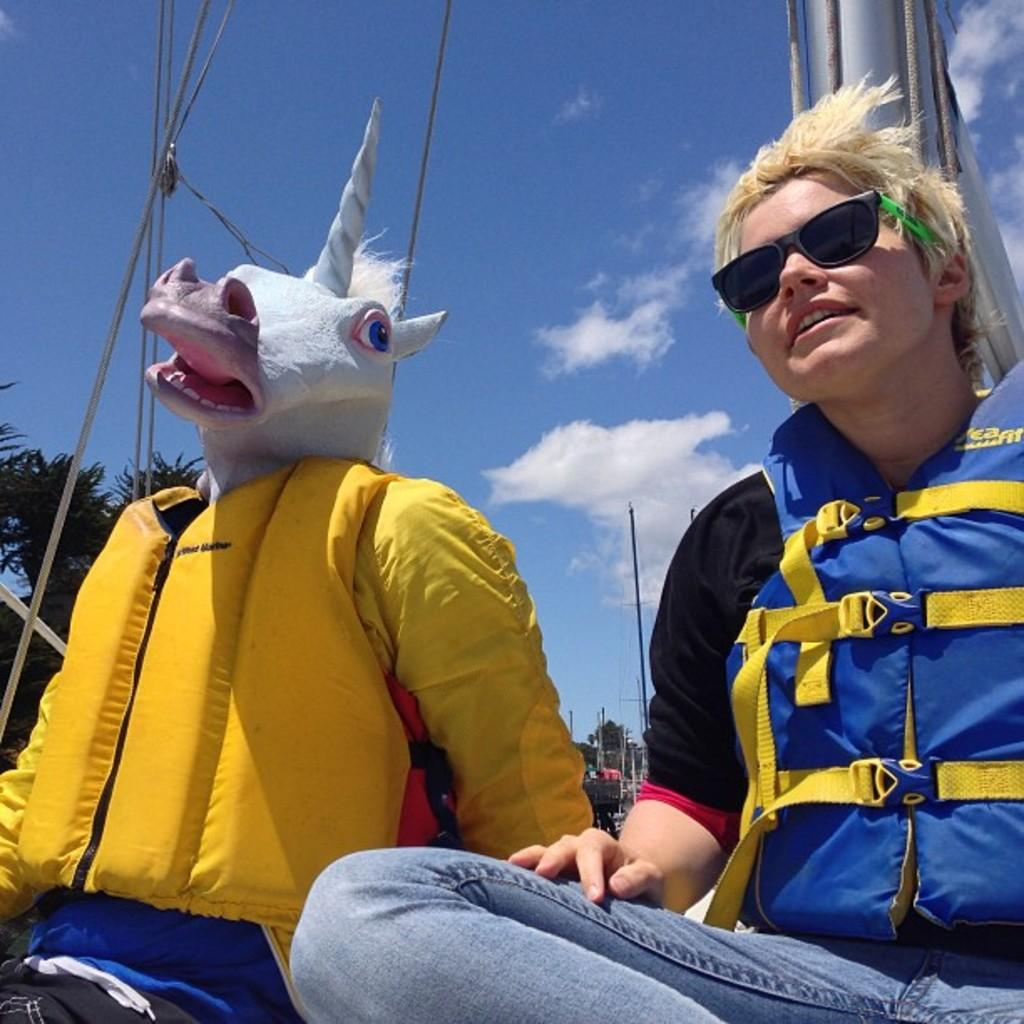What is the person in the image wearing? The person in the image is wearing a different costume. Can you describe the clothing of the other person in the image? The other person is wearing a blue jacket. What can be seen in the background of the image? Trees and poles are visible in the background of the image. What is the color of the sky in the image? The sky is blue and white in color. How much profit does the cactus in the image generate? There is no cactus present in the image, so it is not possible to determine any profit generated. 